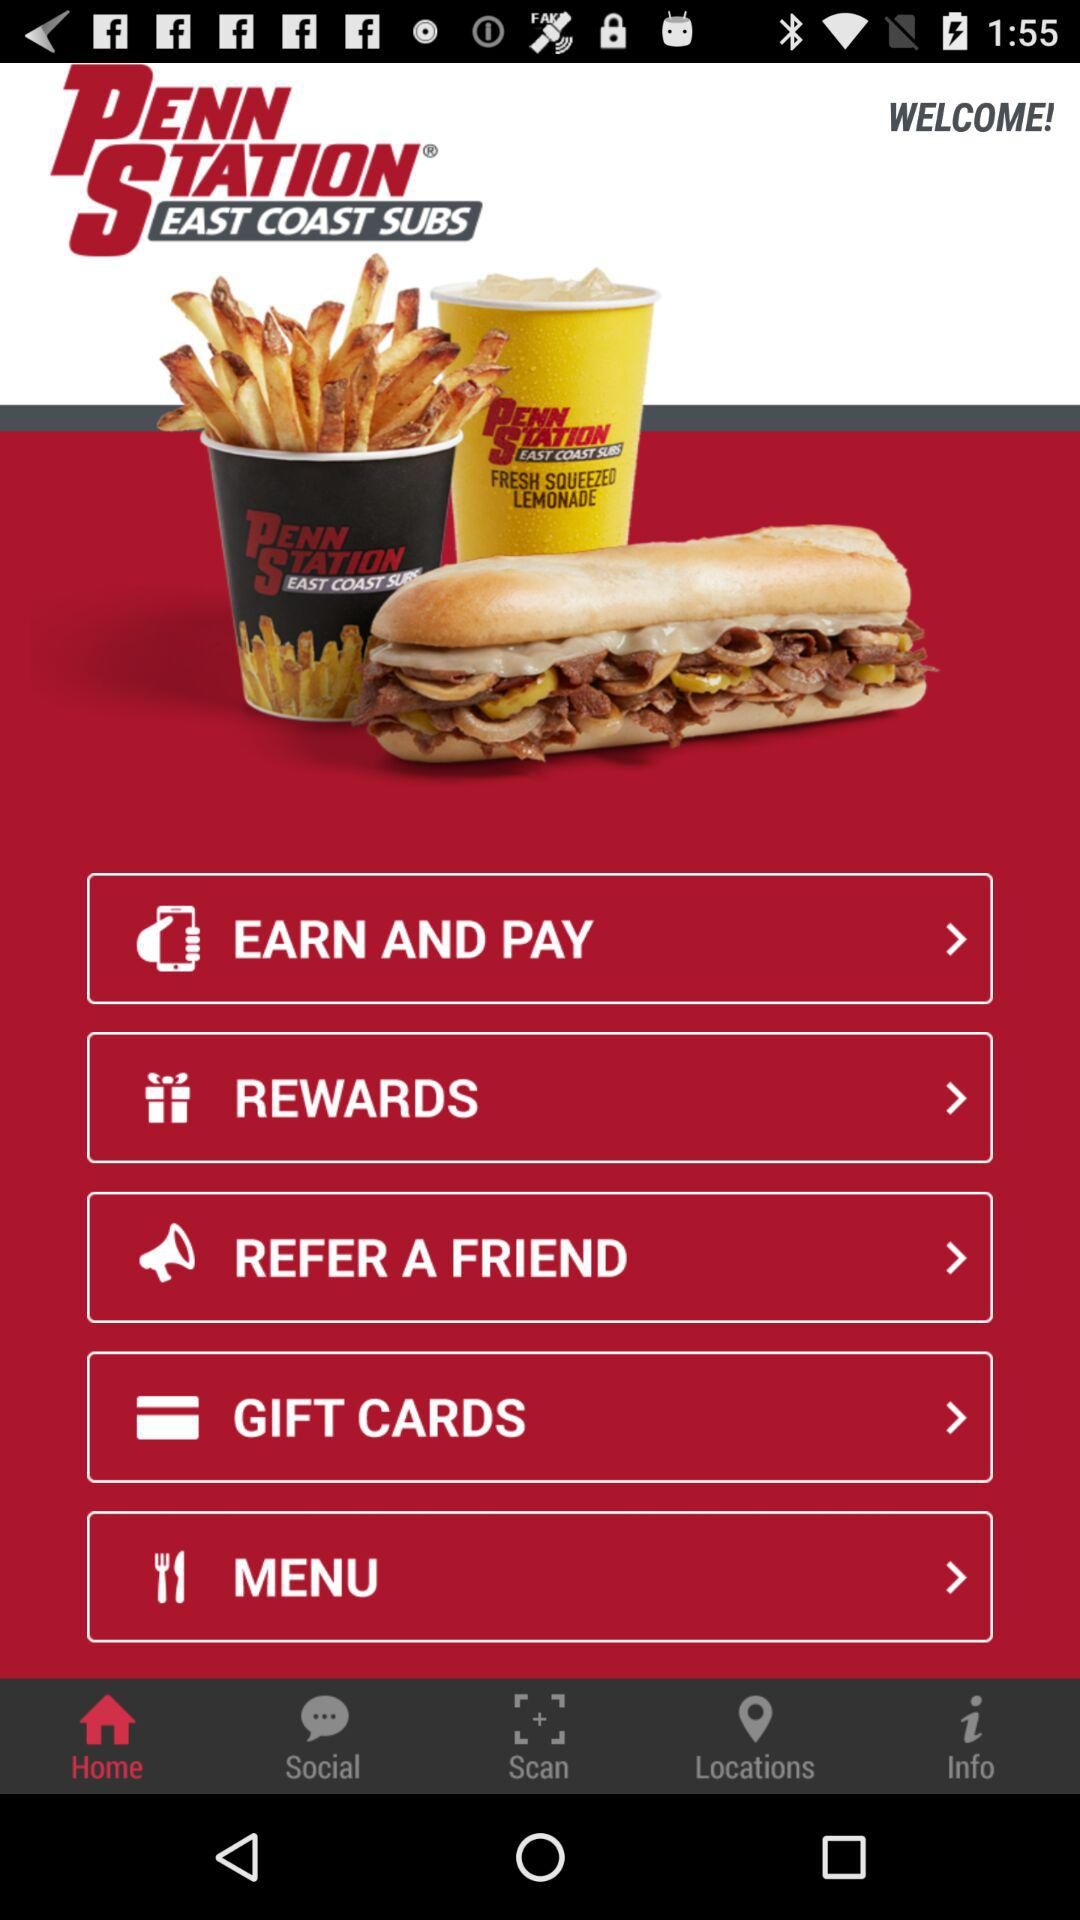What is the name of the application? The name of the application is "PENN STATION® EAST COAST SUBS". 